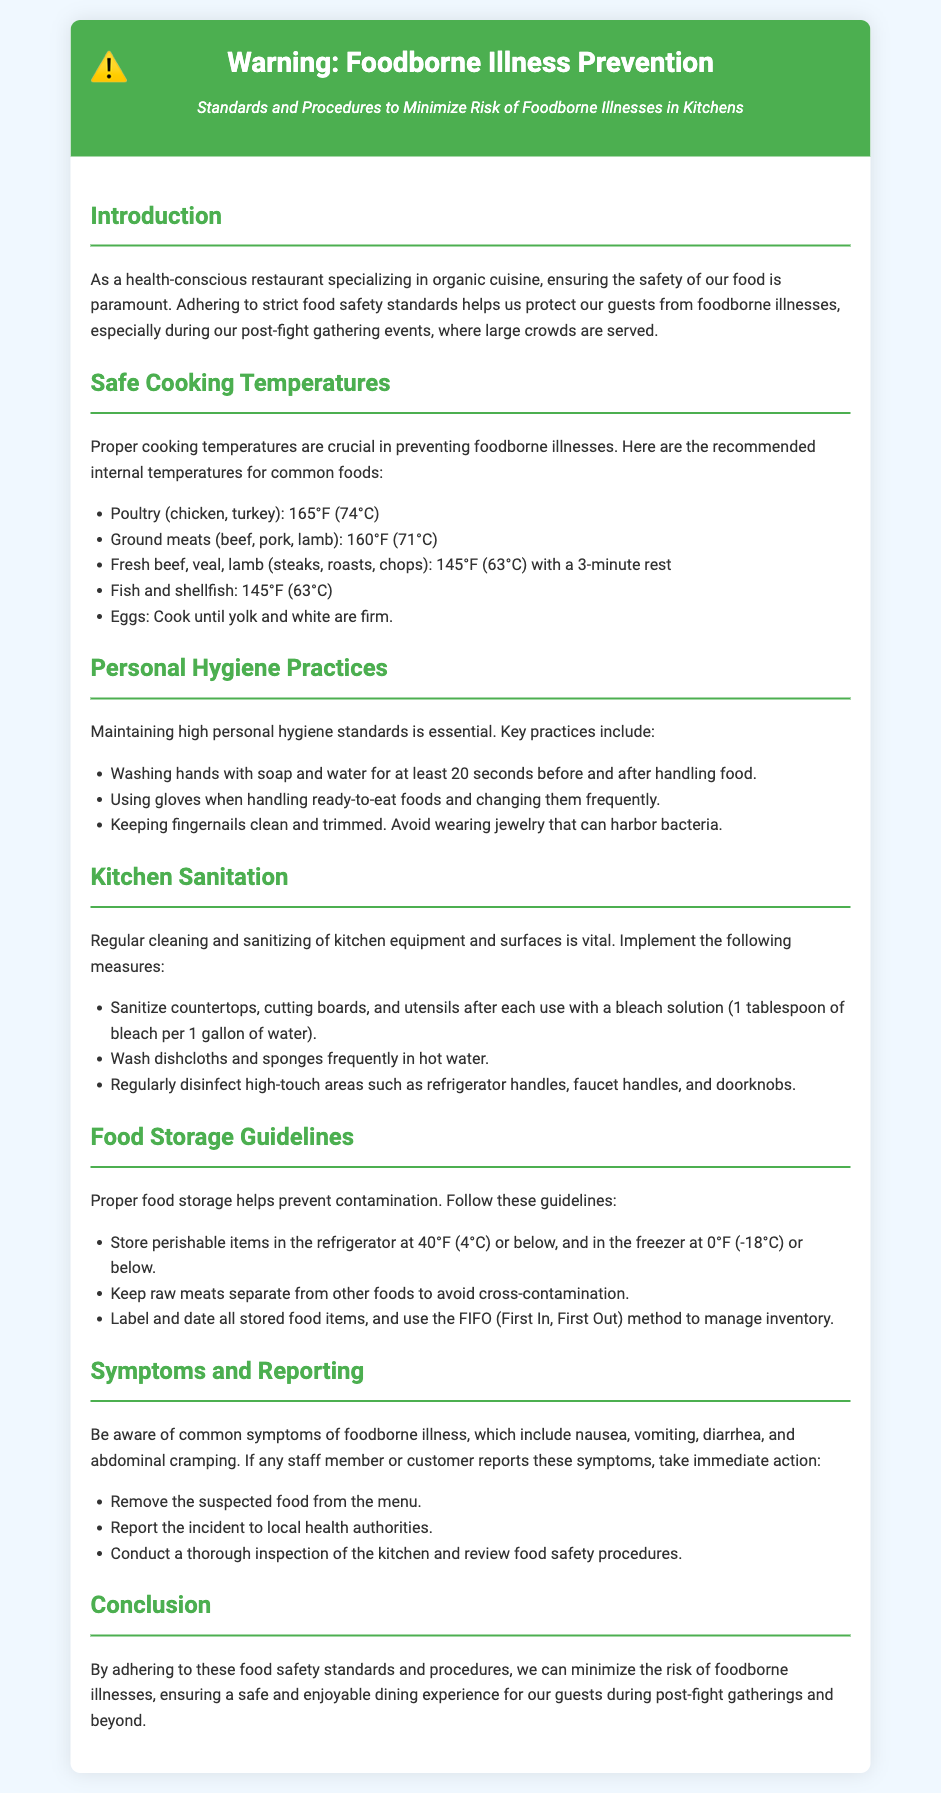what is the recommended cooking temperature for poultry? The document specifies that poultry (chicken, turkey) should be cooked to an internal temperature of 165°F (74°C).
Answer: 165°F (74°C) what should be done if a customer reports symptoms of foodborne illness? According to the document, immediate actions include removing the suspected food from the menu and reporting the incident to local health authorities.
Answer: Remove the suspected food and report to health authorities what is the safe storage temperature for perishable items? The document states that perishable items should be stored in the refrigerator at 40°F (4°C) or below.
Answer: 40°F (4°C) what is the minimum internal cooking temperature for ground meats? The document indicates that ground meats (beef, pork, lamb) should be cooked to an internal temperature of 160°F (71°C).
Answer: 160°F (71°C) how long should hands be washed before and after handling food? The document specifies that hands should be washed with soap and water for at least 20 seconds.
Answer: 20 seconds what method is recommended for managing food inventory? The document suggests using the FIFO (First In, First Out) method for managing inventory.
Answer: FIFO (First In, First Out) what cleaning solution ratio is recommended for sanitizing kitchen surfaces? The document advises using a bleach solution of 1 tablespoon of bleach per 1 gallon of water for sanitizing.
Answer: 1 tablespoon of bleach per 1 gallon of water what are the symptoms of foodborne illness? The common symptoms of foodborne illness include nausea, vomiting, diarrhea, and abdominal cramping, as stated in the document.
Answer: Nausea, vomiting, diarrhea, abdominal cramping what ensures a safe and enjoyable dining experience for guests? The conclusion emphasizes that adhering to food safety standards and procedures minimizes the risk of foodborne illnesses to ensure a safe dining experience.
Answer: Adhering to food safety standards and procedures 